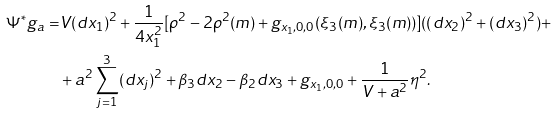<formula> <loc_0><loc_0><loc_500><loc_500>\Psi ^ { * } g _ { a } = & V ( d x _ { 1 } ) ^ { 2 } + \frac { 1 } { 4 x _ { 1 } ^ { 2 } } [ \rho ^ { 2 } - 2 \rho ^ { 2 } ( m ) + g _ { x _ { 1 } , 0 , 0 } ( \xi _ { 3 } ( m ) , \xi _ { 3 } ( m ) ) ] ( ( d x _ { 2 } ) ^ { 2 } + ( d x _ { 3 } ) ^ { 2 } ) + \\ & + a ^ { 2 } \sum _ { j = 1 } ^ { 3 } ( d x _ { j } ) ^ { 2 } + \beta _ { 3 } d x _ { 2 } - \beta _ { 2 } d x _ { 3 } + g _ { x _ { 1 } , 0 , 0 } + \frac { 1 } { V + a ^ { 2 } } \eta ^ { 2 } .</formula> 